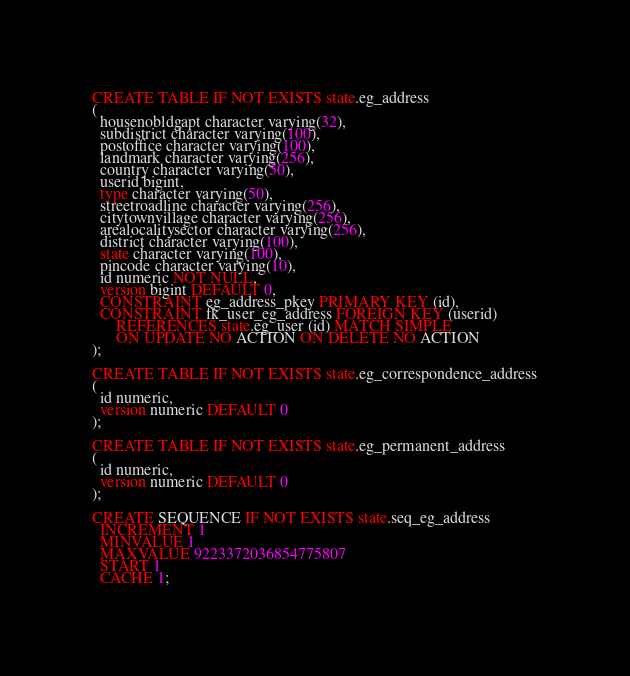<code> <loc_0><loc_0><loc_500><loc_500><_SQL_>CREATE TABLE IF NOT EXISTS state.eg_address
(
  housenobldgapt character varying(32),
  subdistrict character varying(100),
  postoffice character varying(100),
  landmark character varying(256),
  country character varying(50),
  userid bigint,
  type character varying(50),
  streetroadline character varying(256),
  citytownvillage character varying(256),
  arealocalitysector character varying(256),
  district character varying(100),
  state character varying(100),
  pincode character varying(10),
  id numeric NOT NULL,
  version bigint DEFAULT 0,
  CONSTRAINT eg_address_pkey PRIMARY KEY (id),
  CONSTRAINT fk_user_eg_address FOREIGN KEY (userid)
      REFERENCES state.eg_user (id) MATCH SIMPLE
      ON UPDATE NO ACTION ON DELETE NO ACTION
);

CREATE TABLE IF NOT EXISTS state.eg_correspondence_address
(
  id numeric,
  version numeric DEFAULT 0
);

CREATE TABLE IF NOT EXISTS state.eg_permanent_address
(
  id numeric,
  version numeric DEFAULT 0
);

CREATE SEQUENCE IF NOT EXISTS state.seq_eg_address
  INCREMENT 1
  MINVALUE 1
  MAXVALUE 9223372036854775807
  START 1
  CACHE 1;</code> 